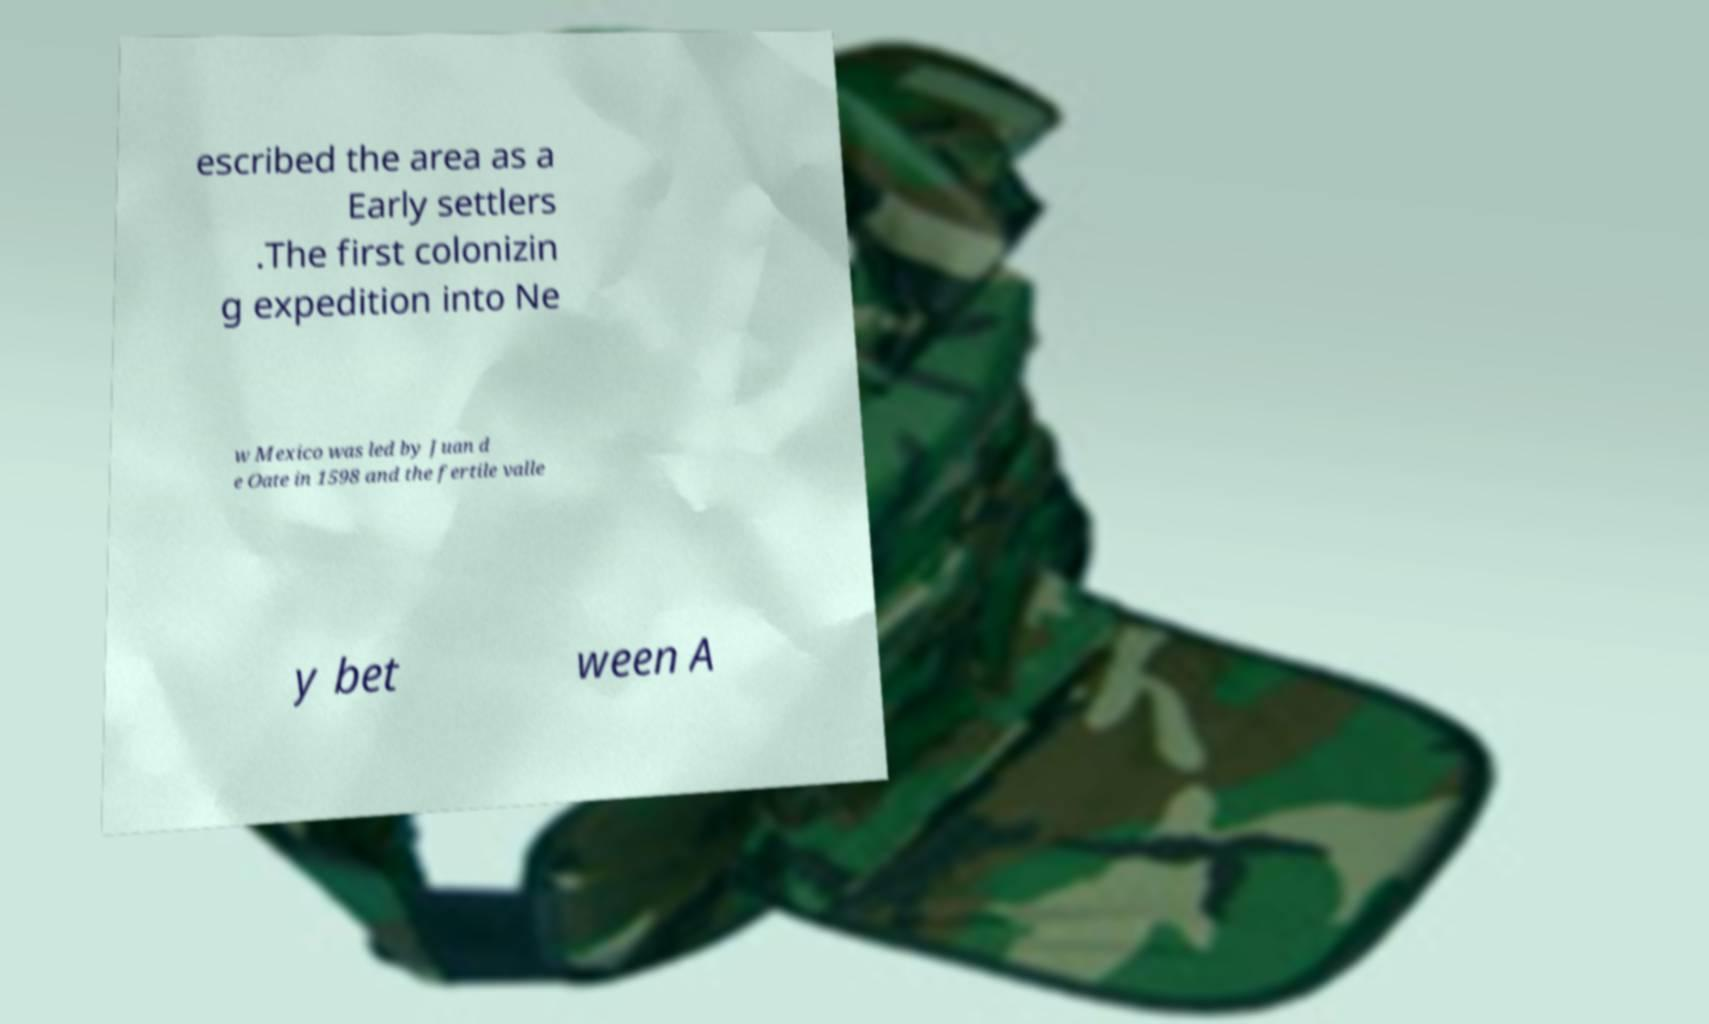Can you read and provide the text displayed in the image?This photo seems to have some interesting text. Can you extract and type it out for me? escribed the area as a Early settlers .The first colonizin g expedition into Ne w Mexico was led by Juan d e Oate in 1598 and the fertile valle y bet ween A 